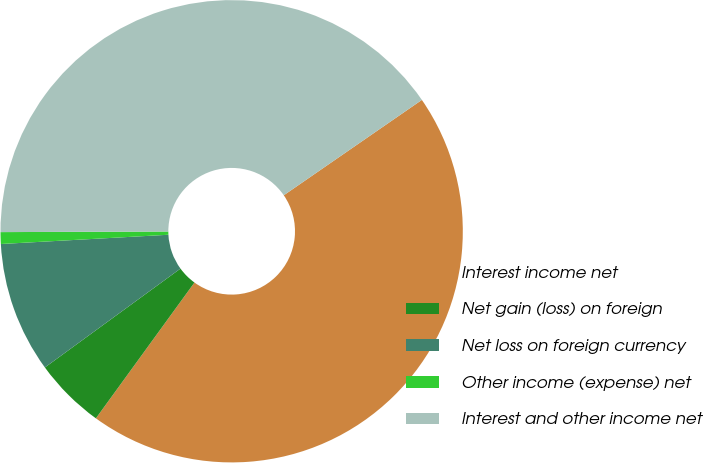Convert chart to OTSL. <chart><loc_0><loc_0><loc_500><loc_500><pie_chart><fcel>Interest income net<fcel>Net gain (loss) on foreign<fcel>Net loss on foreign currency<fcel>Other income (expense) net<fcel>Interest and other income net<nl><fcel>44.61%<fcel>4.98%<fcel>9.15%<fcel>0.82%<fcel>40.44%<nl></chart> 